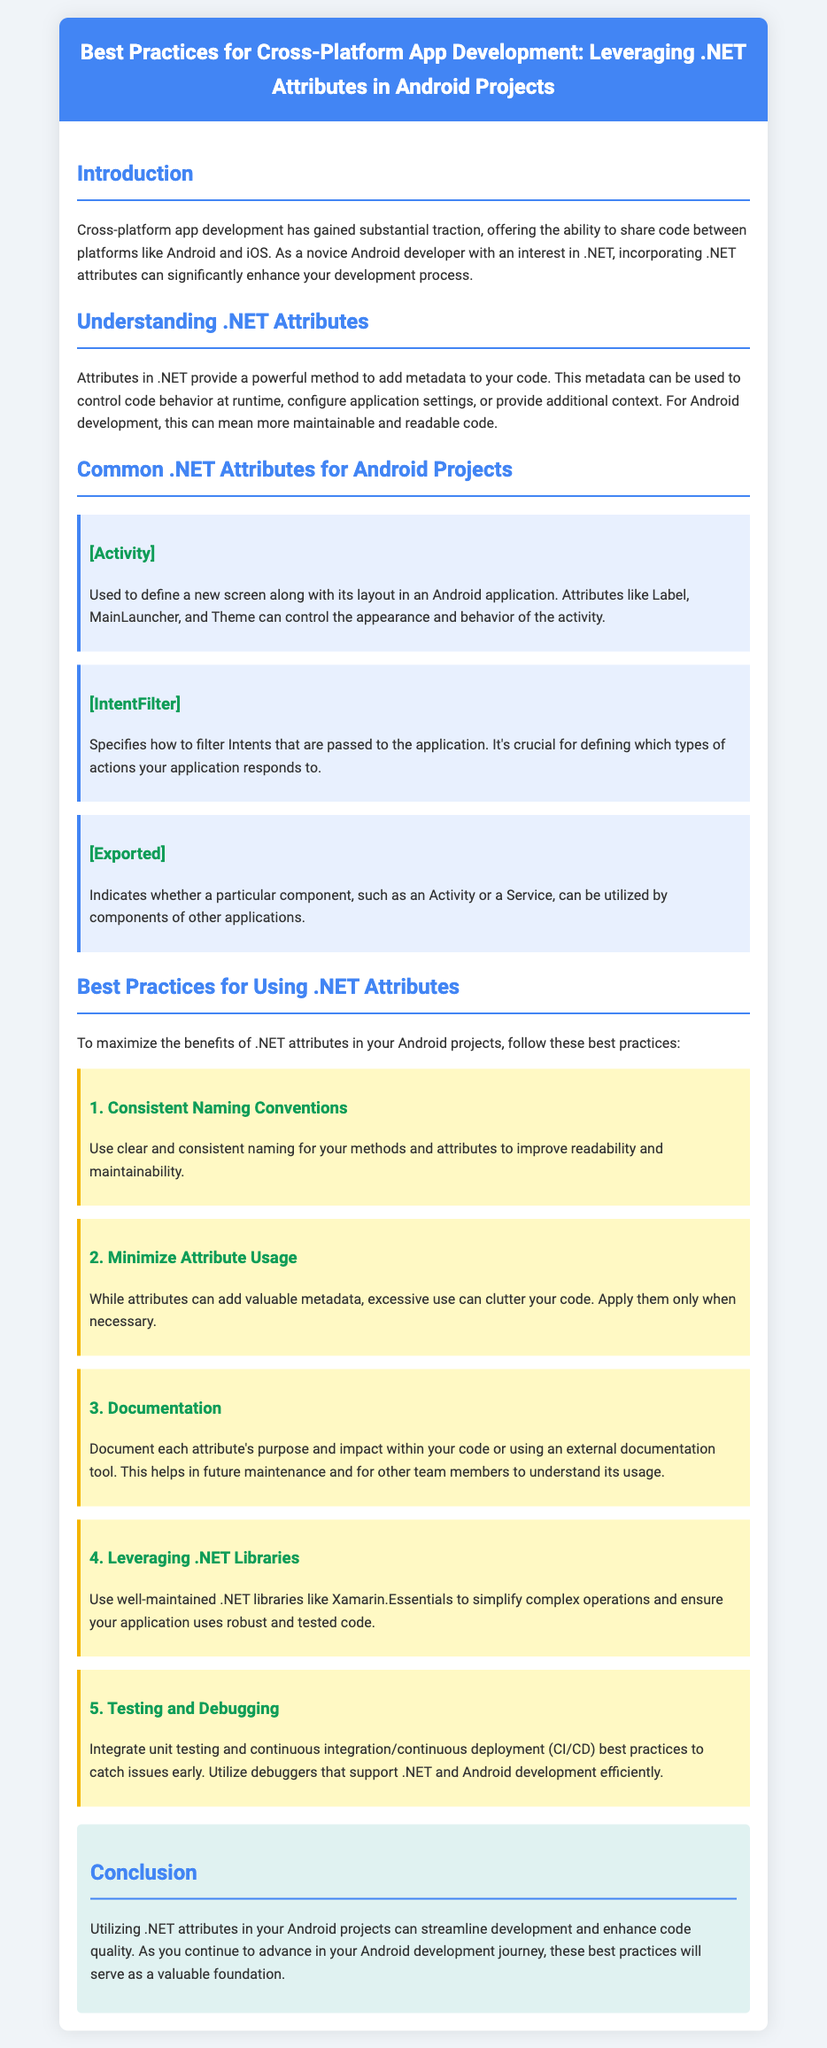what is the title of the document? The title of the document is displayed prominently in the header section, summarizing its focus on best practices for cross-platform app development with .NET attributes in Android projects.
Answer: Best Practices for Cross-Platform App Development: Leveraging .NET Attributes in Android Projects what is the purpose of .NET attributes in Android development? The purpose of .NET attributes is detailed in the document, describing how they provide a method to add metadata to code, influencing behavior, settings, and readability.
Answer: Adding metadata which attribute is used to define a new screen in an Android application? The document contains a section describing common .NET attributes, specifically detailing the use of the [Activity] attribute for defining a new screen and its layout.
Answer: [Activity] how many best practices are listed in the document? The document outlines several practices aimed at maximizing the benefits of .NET attributes, totaling five distinct best practices.
Answer: Five what attribute indicates if a component can be utilized by other applications? The document explains the [Exported] attribute's function in indicating whether a component can be accessed by other applications.
Answer: [Exported] what is one recommended practice regarding the use of attributes? Among the practices discussed in the document, one emphasizes the importance of minimizing the use of attributes to avoid clutter, suggesting they should be used only when necessary.
Answer: Minimize Attribute Usage what is the background color of the conclusion section? The document describes the visual aspect of the conclusion section, indicating that it has a specific background color and style to set it apart.
Answer: #E0F2F1 which library is suggested to leverage for simplifying complex operations? The document mentions certain libraries that are beneficial, specifically recommending the use of well-maintained .NET libraries like Xamarin.Essentials for simplifying operations.
Answer: Xamarin.Essentials 